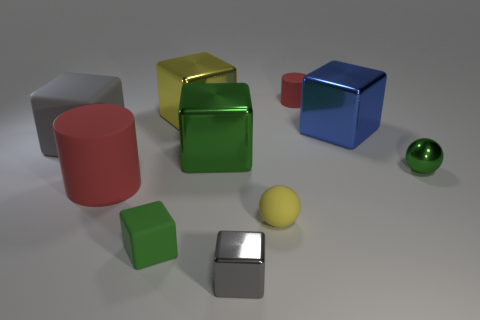Subtract all large gray matte cubes. How many cubes are left? 5 Subtract 2 blocks. How many blocks are left? 4 Subtract all cyan cylinders. How many gray cubes are left? 2 Subtract all blue cubes. How many cubes are left? 5 Subtract all blocks. How many objects are left? 4 Subtract all brown cubes. Subtract all cyan cylinders. How many cubes are left? 6 Subtract all red rubber cylinders. Subtract all cubes. How many objects are left? 2 Add 5 gray cubes. How many gray cubes are left? 7 Add 8 red cylinders. How many red cylinders exist? 10 Subtract 1 yellow balls. How many objects are left? 9 